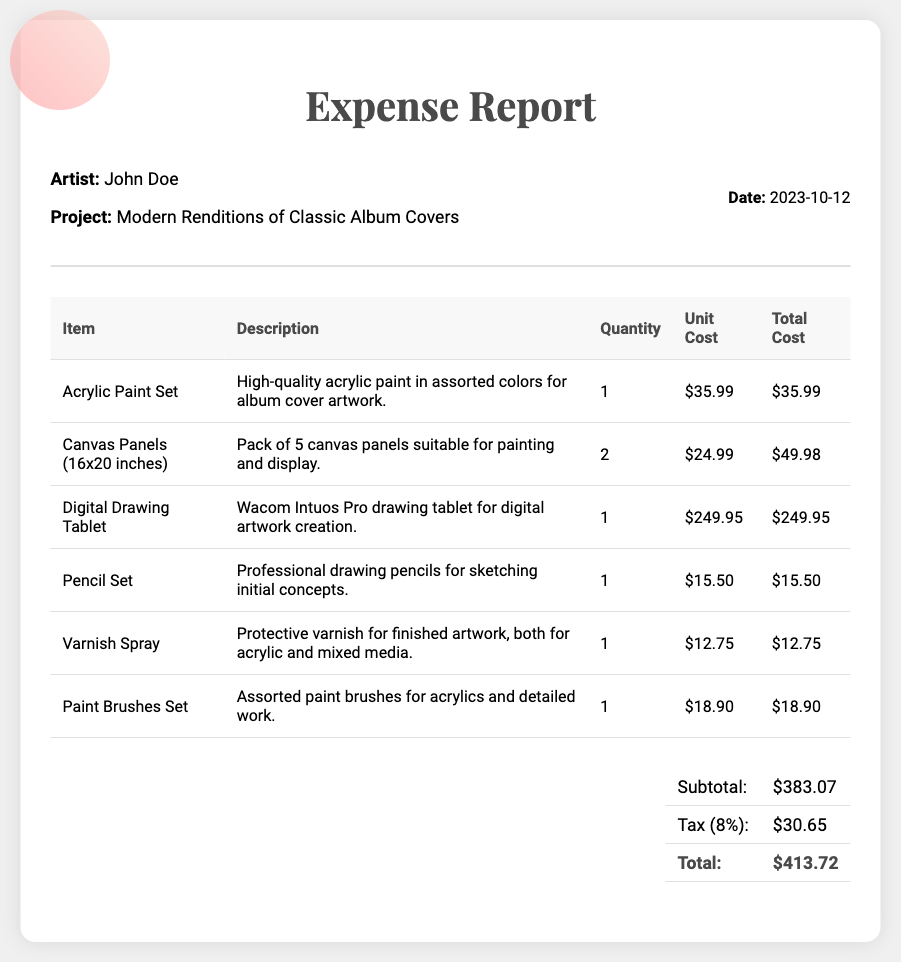What is the artist's name? The artist's name is specified in the document under the artist info section.
Answer: John Doe What is the date of the expense report? The date is noted in the document and indicates when the report was created.
Answer: 2023-10-12 How many canvas panels were purchased? The quantity of canvas panels is listed in the itemized table of the document.
Answer: 2 What is the total cost of the acrylic paint set? The total cost for the acrylic paint set is provided in the total cost column of the expense table.
Answer: $35.99 What is the subtotal amount before tax? The subtotal is explicitly mentioned in the totals section of the document.
Answer: $383.07 How much tax was applied to the total cost? The document specifies the tax amount in the totals section, calculated as 8% of the subtotal.
Answer: $30.65 What is the total amount due for the expenses? The total amount is the final sum required, listing in the totals section of the document.
Answer: $413.72 What type of digital tool was purchased? The document includes a specific description of the digital tool in the items listed.
Answer: Digital Drawing Tablet Which item has the highest cost? The highest cost item can be identified by comparing total costs in the expense table.
Answer: Digital Drawing Tablet 